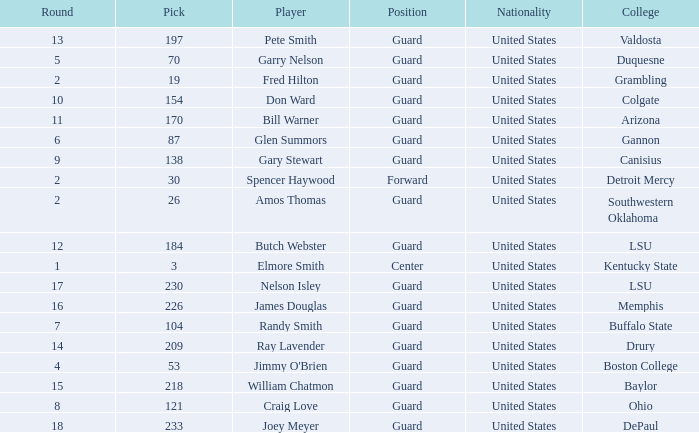WHAT POSITION HAS A ROUND LARGER THAN 2, FOR VALDOSTA COLLEGE? Guard. 